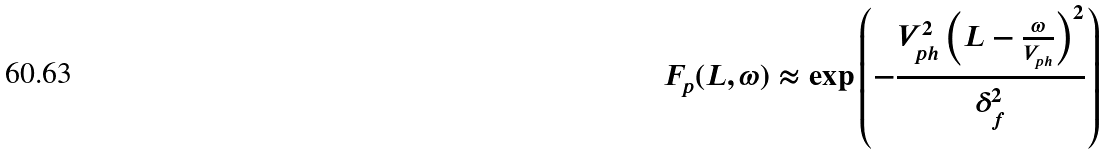<formula> <loc_0><loc_0><loc_500><loc_500>F _ { p } ( L , \omega ) \approx \exp \left ( - \frac { V _ { p h } ^ { 2 } \left ( L - \frac { \omega } { V _ { p h } } \right ) ^ { 2 } } { \delta _ { f } ^ { 2 } } \right )</formula> 